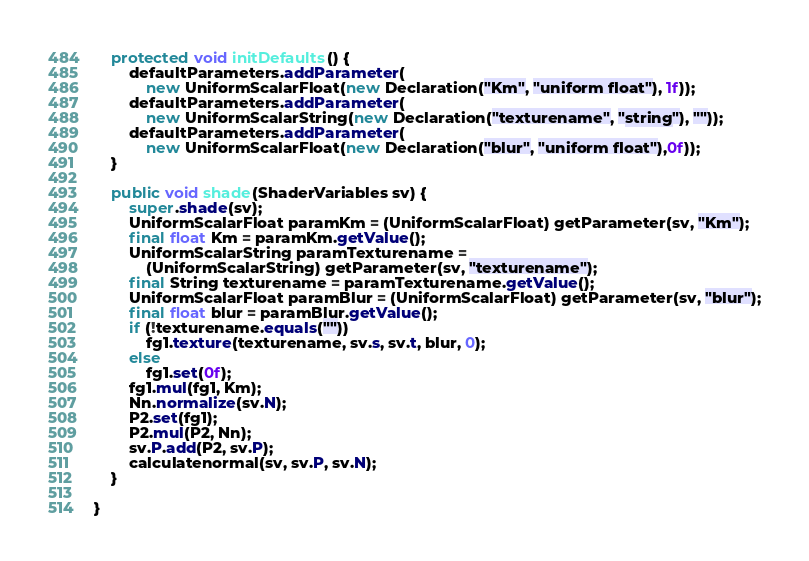Convert code to text. <code><loc_0><loc_0><loc_500><loc_500><_Java_>    protected void initDefaults() {
        defaultParameters.addParameter(
            new UniformScalarFloat(new Declaration("Km", "uniform float"), 1f));
        defaultParameters.addParameter(
            new UniformScalarString(new Declaration("texturename", "string"), ""));
        defaultParameters.addParameter(
            new UniformScalarFloat(new Declaration("blur", "uniform float"),0f));
    }

    public void shade(ShaderVariables sv) {
        super.shade(sv);
        UniformScalarFloat paramKm = (UniformScalarFloat) getParameter(sv, "Km");
        final float Km = paramKm.getValue();
        UniformScalarString paramTexturename =
            (UniformScalarString) getParameter(sv, "texturename");
        final String texturename = paramTexturename.getValue();
        UniformScalarFloat paramBlur = (UniformScalarFloat) getParameter(sv, "blur");
        final float blur = paramBlur.getValue();
        if (!texturename.equals(""))
            fg1.texture(texturename, sv.s, sv.t, blur, 0);
        else
            fg1.set(0f);
        fg1.mul(fg1, Km);
        Nn.normalize(sv.N);
        P2.set(fg1);
        P2.mul(P2, Nn);
        sv.P.add(P2, sv.P);
        calculatenormal(sv, sv.P, sv.N);
    }

}
</code> 